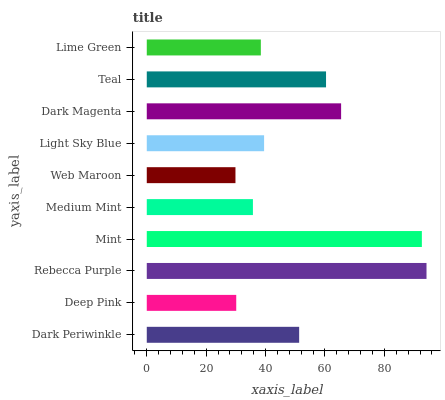Is Web Maroon the minimum?
Answer yes or no. Yes. Is Rebecca Purple the maximum?
Answer yes or no. Yes. Is Deep Pink the minimum?
Answer yes or no. No. Is Deep Pink the maximum?
Answer yes or no. No. Is Dark Periwinkle greater than Deep Pink?
Answer yes or no. Yes. Is Deep Pink less than Dark Periwinkle?
Answer yes or no. Yes. Is Deep Pink greater than Dark Periwinkle?
Answer yes or no. No. Is Dark Periwinkle less than Deep Pink?
Answer yes or no. No. Is Dark Periwinkle the high median?
Answer yes or no. Yes. Is Light Sky Blue the low median?
Answer yes or no. Yes. Is Deep Pink the high median?
Answer yes or no. No. Is Dark Periwinkle the low median?
Answer yes or no. No. 